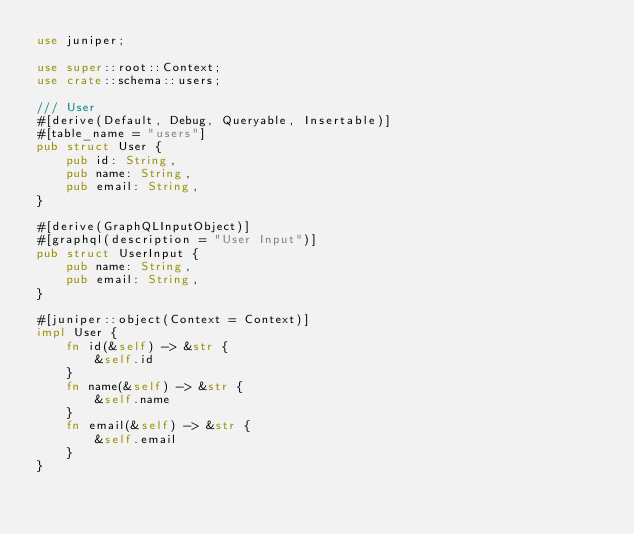Convert code to text. <code><loc_0><loc_0><loc_500><loc_500><_Rust_>use juniper;

use super::root::Context;
use crate::schema::users;

/// User
#[derive(Default, Debug, Queryable, Insertable)]
#[table_name = "users"]
pub struct User {
    pub id: String,
    pub name: String,
    pub email: String,
}

#[derive(GraphQLInputObject)]
#[graphql(description = "User Input")]
pub struct UserInput {
    pub name: String,
    pub email: String,
}

#[juniper::object(Context = Context)]
impl User {
    fn id(&self) -> &str {
        &self.id
    }
    fn name(&self) -> &str {
        &self.name
    }
    fn email(&self) -> &str {
        &self.email
    }
}
</code> 